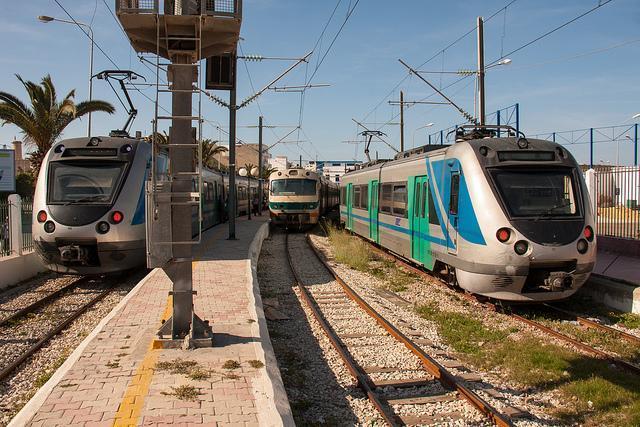How many trains are in this picture?
Give a very brief answer. 3. How many trains are there?
Give a very brief answer. 3. How many trains are visible?
Give a very brief answer. 3. 